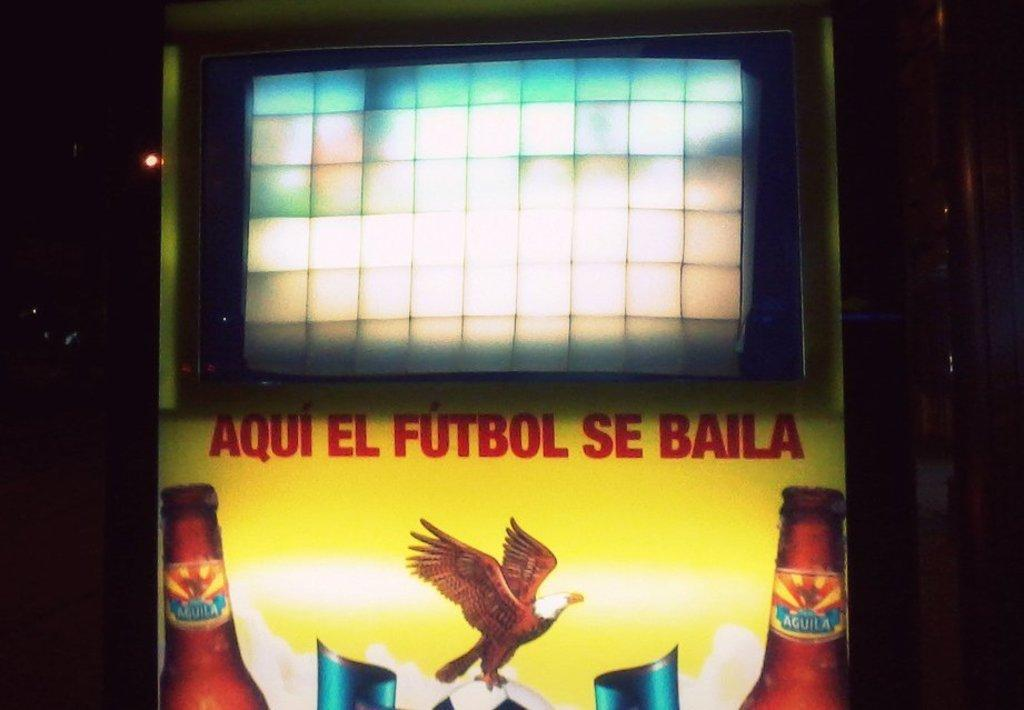<image>
Offer a succinct explanation of the picture presented. two bottles and a bird are on a poster with the word Futbol in red. 